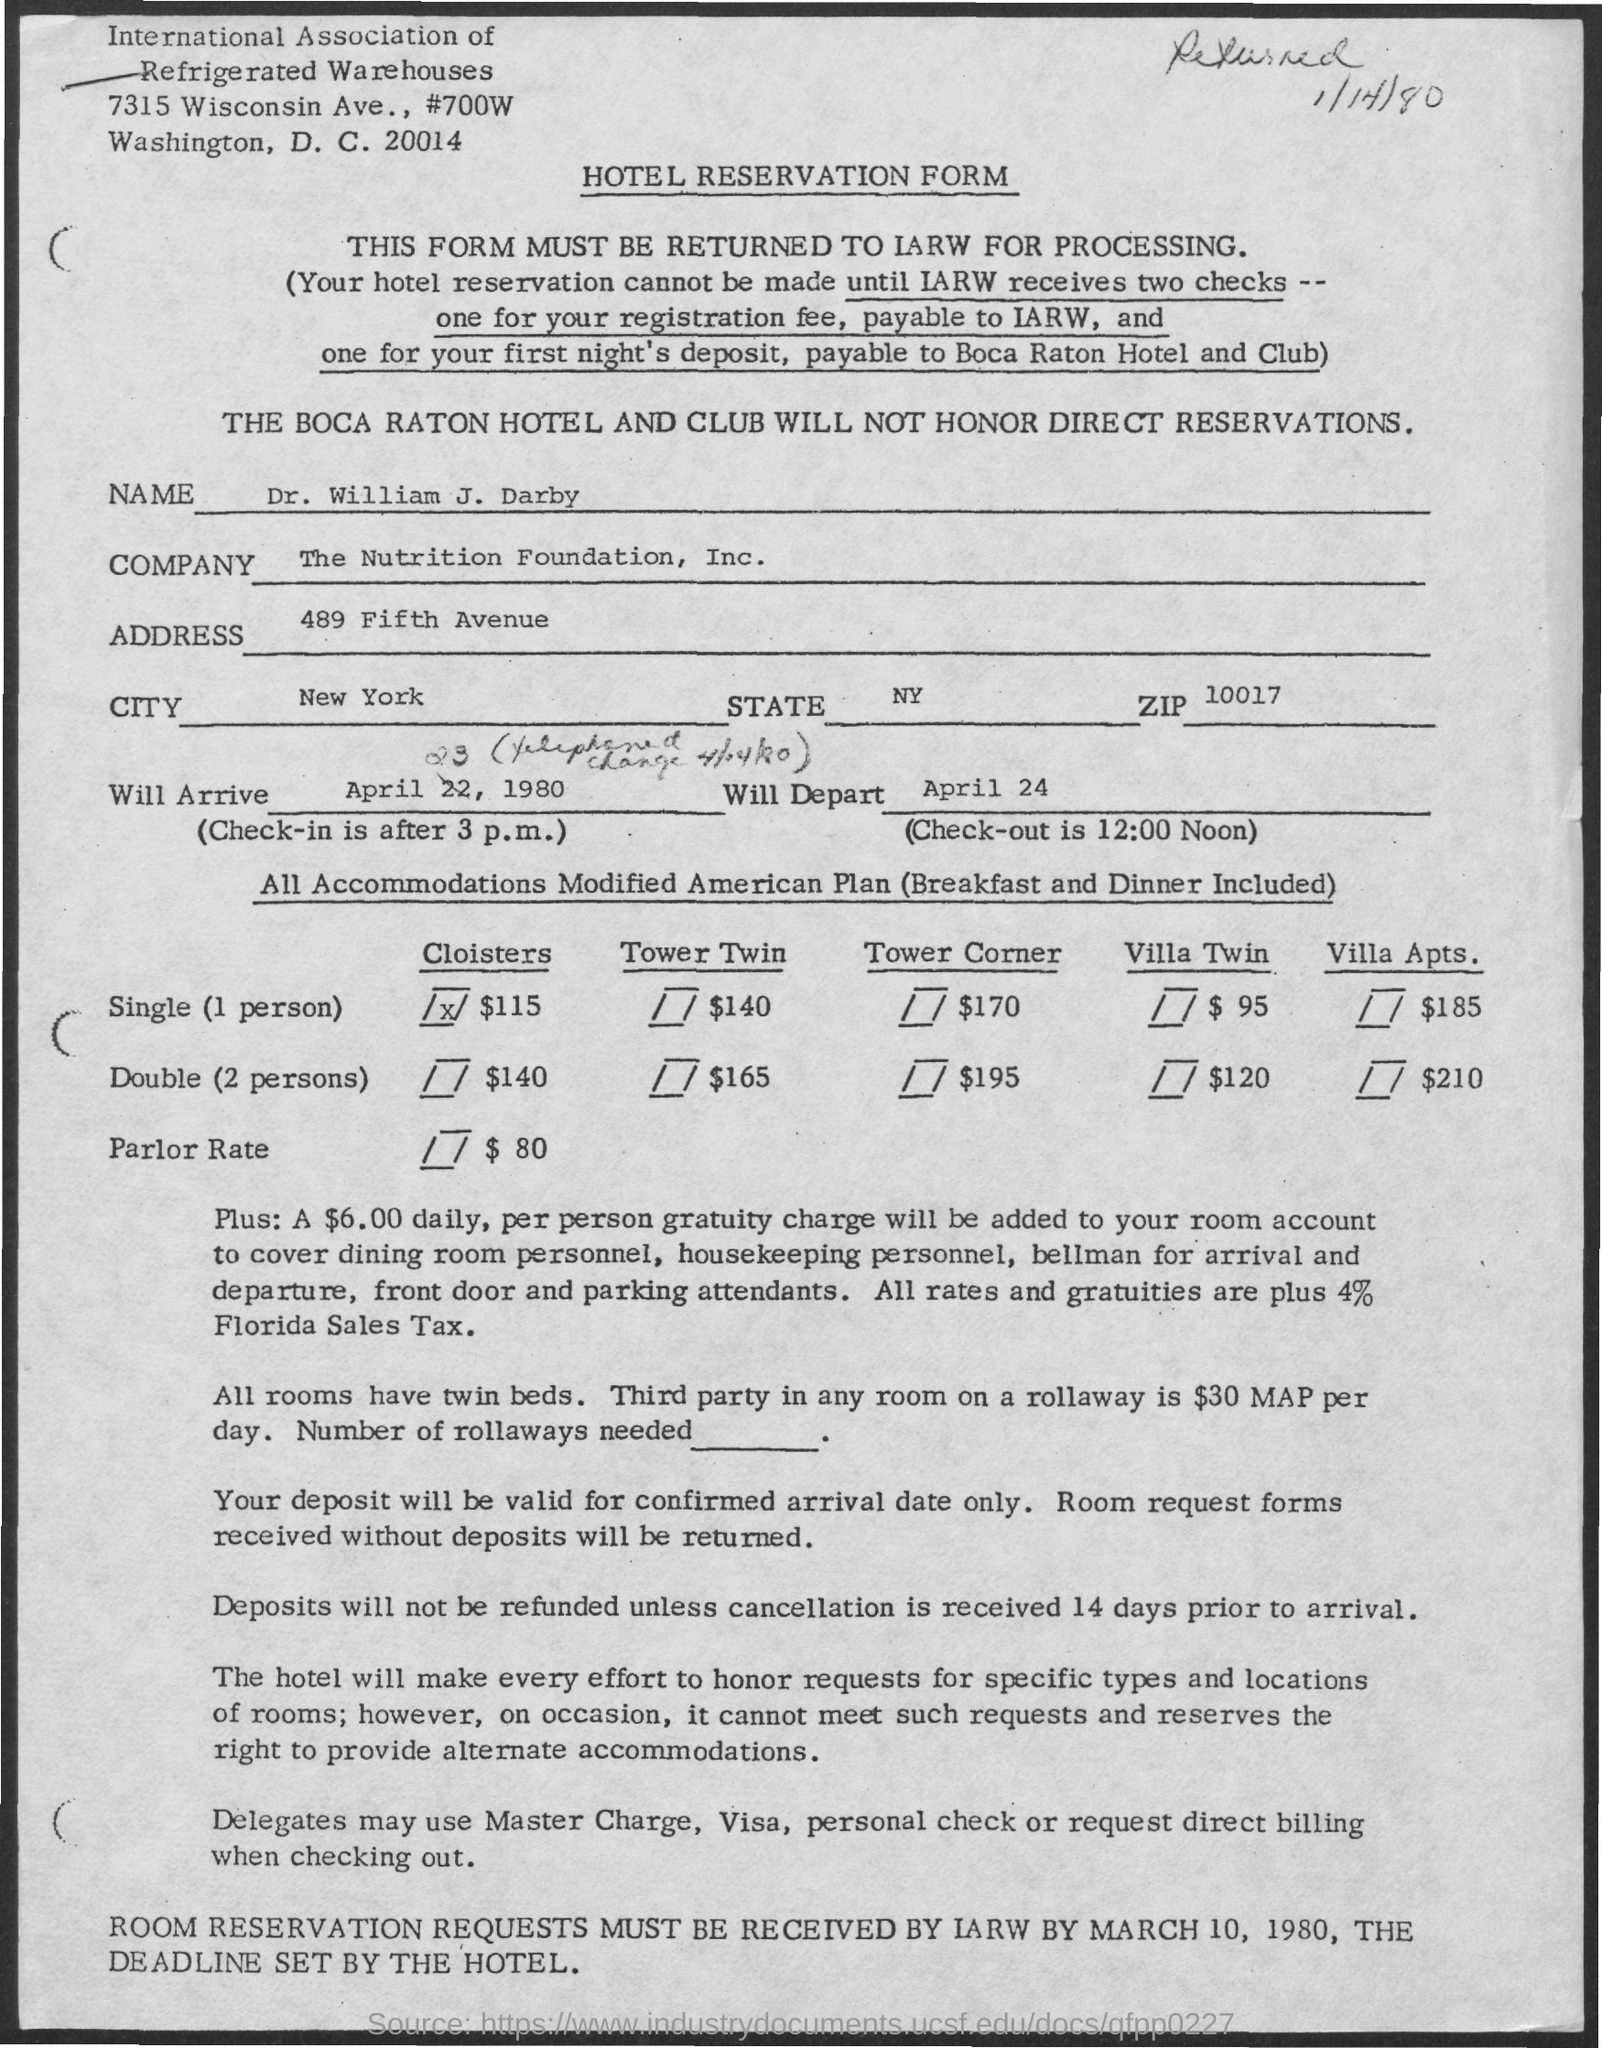What types of rooms can be reserved and what are the rates? The form lists several room options such as Cloister Single, Tower Twin, Tower Corner, Villa Twin, and Villa Suites with rates varying from $115 to $210 depending on the type and whether it's for a single or double occupancy. Are there any additional charges mentioned? Yes, there's a $6.00 daily, per person gratuity charge on top of the room rates. This charge covers various personnel services and includes a 4% Florida Sales Tax. 